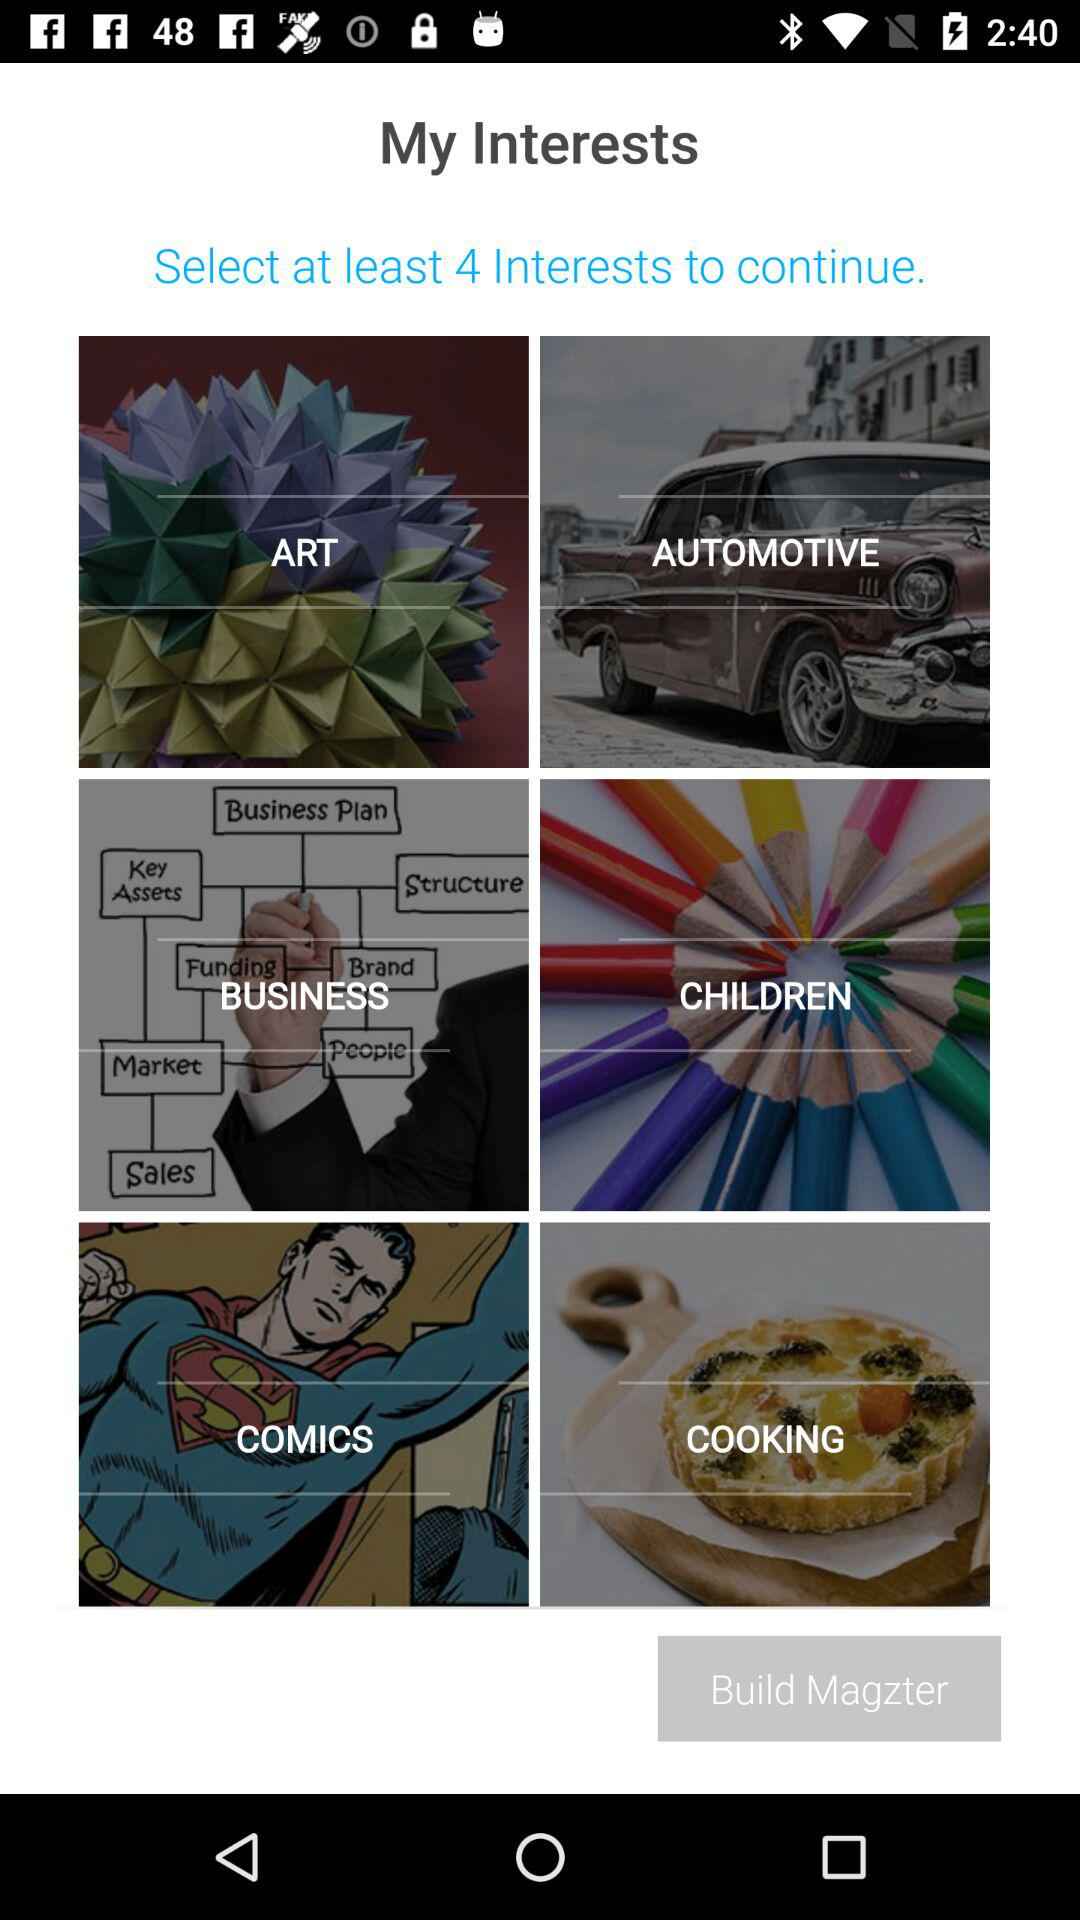How many interests need to be selected? There are 4 interests that need to be selected. 